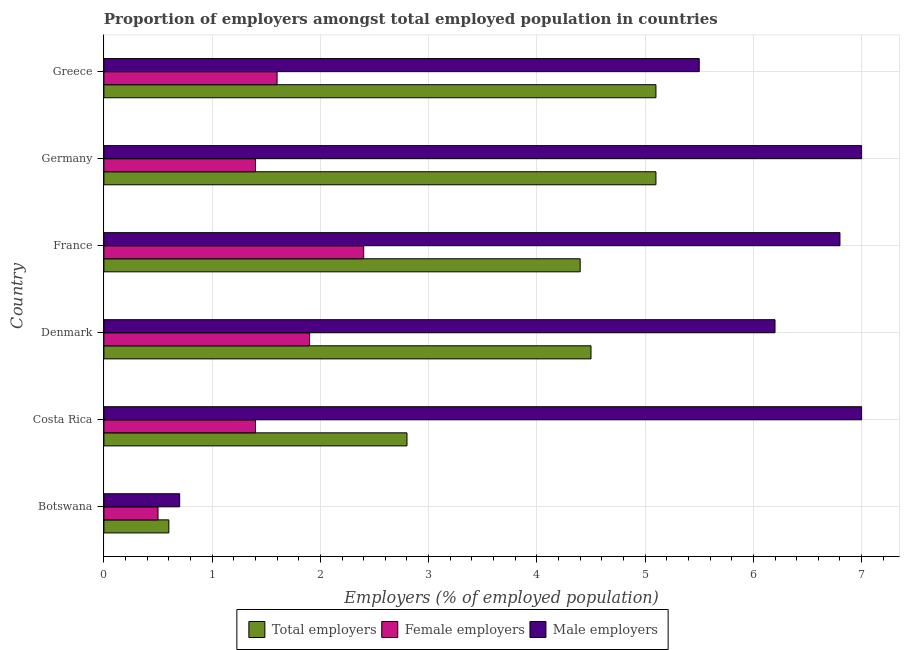How many different coloured bars are there?
Your answer should be very brief. 3. How many groups of bars are there?
Offer a very short reply. 6. Are the number of bars on each tick of the Y-axis equal?
Your response must be concise. Yes. How many bars are there on the 5th tick from the top?
Offer a very short reply. 3. How many bars are there on the 2nd tick from the bottom?
Keep it short and to the point. 3. In how many cases, is the number of bars for a given country not equal to the number of legend labels?
Ensure brevity in your answer.  0. What is the percentage of female employers in France?
Give a very brief answer. 2.4. Across all countries, what is the minimum percentage of female employers?
Provide a short and direct response. 0.5. In which country was the percentage of female employers maximum?
Make the answer very short. France. In which country was the percentage of male employers minimum?
Ensure brevity in your answer.  Botswana. What is the total percentage of male employers in the graph?
Give a very brief answer. 33.2. What is the difference between the percentage of female employers in Botswana and that in Greece?
Your answer should be compact. -1.1. What is the difference between the percentage of total employers in Costa Rica and the percentage of male employers in Denmark?
Your response must be concise. -3.4. What is the average percentage of male employers per country?
Make the answer very short. 5.53. What is the ratio of the percentage of total employers in Costa Rica to that in Germany?
Offer a very short reply. 0.55. Is the percentage of female employers in Costa Rica less than that in Greece?
Provide a short and direct response. Yes. What is the difference between the highest and the second highest percentage of female employers?
Offer a terse response. 0.5. What does the 1st bar from the top in Denmark represents?
Provide a short and direct response. Male employers. What does the 1st bar from the bottom in Botswana represents?
Your answer should be compact. Total employers. How many bars are there?
Give a very brief answer. 18. Are all the bars in the graph horizontal?
Your answer should be compact. Yes. How many countries are there in the graph?
Provide a succinct answer. 6. What is the difference between two consecutive major ticks on the X-axis?
Ensure brevity in your answer.  1. Are the values on the major ticks of X-axis written in scientific E-notation?
Provide a short and direct response. No. Does the graph contain grids?
Make the answer very short. Yes. Where does the legend appear in the graph?
Offer a terse response. Bottom center. What is the title of the graph?
Make the answer very short. Proportion of employers amongst total employed population in countries. Does "Methane" appear as one of the legend labels in the graph?
Make the answer very short. No. What is the label or title of the X-axis?
Your response must be concise. Employers (% of employed population). What is the Employers (% of employed population) in Total employers in Botswana?
Your answer should be compact. 0.6. What is the Employers (% of employed population) of Female employers in Botswana?
Offer a very short reply. 0.5. What is the Employers (% of employed population) in Male employers in Botswana?
Your answer should be compact. 0.7. What is the Employers (% of employed population) of Total employers in Costa Rica?
Give a very brief answer. 2.8. What is the Employers (% of employed population) in Female employers in Costa Rica?
Make the answer very short. 1.4. What is the Employers (% of employed population) in Male employers in Costa Rica?
Provide a succinct answer. 7. What is the Employers (% of employed population) of Total employers in Denmark?
Your answer should be compact. 4.5. What is the Employers (% of employed population) in Female employers in Denmark?
Keep it short and to the point. 1.9. What is the Employers (% of employed population) in Male employers in Denmark?
Your answer should be compact. 6.2. What is the Employers (% of employed population) in Total employers in France?
Give a very brief answer. 4.4. What is the Employers (% of employed population) in Female employers in France?
Your response must be concise. 2.4. What is the Employers (% of employed population) in Male employers in France?
Your answer should be compact. 6.8. What is the Employers (% of employed population) of Total employers in Germany?
Your answer should be very brief. 5.1. What is the Employers (% of employed population) of Female employers in Germany?
Make the answer very short. 1.4. What is the Employers (% of employed population) of Total employers in Greece?
Ensure brevity in your answer.  5.1. What is the Employers (% of employed population) in Female employers in Greece?
Your response must be concise. 1.6. Across all countries, what is the maximum Employers (% of employed population) of Total employers?
Provide a succinct answer. 5.1. Across all countries, what is the maximum Employers (% of employed population) of Female employers?
Your response must be concise. 2.4. Across all countries, what is the minimum Employers (% of employed population) in Total employers?
Your answer should be compact. 0.6. Across all countries, what is the minimum Employers (% of employed population) in Female employers?
Ensure brevity in your answer.  0.5. Across all countries, what is the minimum Employers (% of employed population) in Male employers?
Give a very brief answer. 0.7. What is the total Employers (% of employed population) of Male employers in the graph?
Keep it short and to the point. 33.2. What is the difference between the Employers (% of employed population) in Female employers in Botswana and that in Denmark?
Provide a succinct answer. -1.4. What is the difference between the Employers (% of employed population) in Male employers in Botswana and that in Denmark?
Provide a succinct answer. -5.5. What is the difference between the Employers (% of employed population) of Female employers in Botswana and that in France?
Offer a very short reply. -1.9. What is the difference between the Employers (% of employed population) of Female employers in Botswana and that in Germany?
Offer a very short reply. -0.9. What is the difference between the Employers (% of employed population) of Total employers in Botswana and that in Greece?
Provide a succinct answer. -4.5. What is the difference between the Employers (% of employed population) of Female employers in Botswana and that in Greece?
Offer a terse response. -1.1. What is the difference between the Employers (% of employed population) of Male employers in Botswana and that in Greece?
Offer a very short reply. -4.8. What is the difference between the Employers (% of employed population) in Total employers in Costa Rica and that in Denmark?
Offer a terse response. -1.7. What is the difference between the Employers (% of employed population) in Female employers in Costa Rica and that in Denmark?
Keep it short and to the point. -0.5. What is the difference between the Employers (% of employed population) in Male employers in Costa Rica and that in France?
Your response must be concise. 0.2. What is the difference between the Employers (% of employed population) of Total employers in Costa Rica and that in Germany?
Ensure brevity in your answer.  -2.3. What is the difference between the Employers (% of employed population) in Male employers in Costa Rica and that in Germany?
Offer a very short reply. 0. What is the difference between the Employers (% of employed population) in Female employers in Costa Rica and that in Greece?
Your answer should be compact. -0.2. What is the difference between the Employers (% of employed population) in Male employers in Costa Rica and that in Greece?
Provide a short and direct response. 1.5. What is the difference between the Employers (% of employed population) in Female employers in Denmark and that in France?
Offer a terse response. -0.5. What is the difference between the Employers (% of employed population) of Female employers in Denmark and that in Germany?
Give a very brief answer. 0.5. What is the difference between the Employers (% of employed population) in Total employers in Denmark and that in Greece?
Provide a short and direct response. -0.6. What is the difference between the Employers (% of employed population) in Male employers in Denmark and that in Greece?
Provide a succinct answer. 0.7. What is the difference between the Employers (% of employed population) of Male employers in France and that in Germany?
Offer a terse response. -0.2. What is the difference between the Employers (% of employed population) of Male employers in France and that in Greece?
Offer a terse response. 1.3. What is the difference between the Employers (% of employed population) in Female employers in Germany and that in Greece?
Your answer should be compact. -0.2. What is the difference between the Employers (% of employed population) of Male employers in Germany and that in Greece?
Ensure brevity in your answer.  1.5. What is the difference between the Employers (% of employed population) in Total employers in Botswana and the Employers (% of employed population) in Male employers in Costa Rica?
Your response must be concise. -6.4. What is the difference between the Employers (% of employed population) of Female employers in Botswana and the Employers (% of employed population) of Male employers in Costa Rica?
Provide a short and direct response. -6.5. What is the difference between the Employers (% of employed population) of Total employers in Botswana and the Employers (% of employed population) of Female employers in France?
Provide a succinct answer. -1.8. What is the difference between the Employers (% of employed population) of Total employers in Botswana and the Employers (% of employed population) of Male employers in France?
Offer a terse response. -6.2. What is the difference between the Employers (% of employed population) in Female employers in Botswana and the Employers (% of employed population) in Male employers in France?
Offer a very short reply. -6.3. What is the difference between the Employers (% of employed population) of Total employers in Botswana and the Employers (% of employed population) of Female employers in Germany?
Offer a very short reply. -0.8. What is the difference between the Employers (% of employed population) of Total employers in Botswana and the Employers (% of employed population) of Male employers in Germany?
Your answer should be very brief. -6.4. What is the difference between the Employers (% of employed population) in Female employers in Botswana and the Employers (% of employed population) in Male employers in Germany?
Keep it short and to the point. -6.5. What is the difference between the Employers (% of employed population) of Total employers in Botswana and the Employers (% of employed population) of Male employers in Greece?
Provide a succinct answer. -4.9. What is the difference between the Employers (% of employed population) of Female employers in Botswana and the Employers (% of employed population) of Male employers in Greece?
Ensure brevity in your answer.  -5. What is the difference between the Employers (% of employed population) in Total employers in Costa Rica and the Employers (% of employed population) in Male employers in Denmark?
Keep it short and to the point. -3.4. What is the difference between the Employers (% of employed population) in Female employers in Costa Rica and the Employers (% of employed population) in Male employers in France?
Offer a terse response. -5.4. What is the difference between the Employers (% of employed population) in Total employers in Costa Rica and the Employers (% of employed population) in Male employers in Germany?
Your answer should be compact. -4.2. What is the difference between the Employers (% of employed population) in Female employers in Costa Rica and the Employers (% of employed population) in Male employers in Germany?
Keep it short and to the point. -5.6. What is the difference between the Employers (% of employed population) of Female employers in Costa Rica and the Employers (% of employed population) of Male employers in Greece?
Offer a terse response. -4.1. What is the difference between the Employers (% of employed population) of Total employers in Denmark and the Employers (% of employed population) of Female employers in France?
Make the answer very short. 2.1. What is the difference between the Employers (% of employed population) in Total employers in Denmark and the Employers (% of employed population) in Male employers in France?
Your response must be concise. -2.3. What is the difference between the Employers (% of employed population) in Female employers in Denmark and the Employers (% of employed population) in Male employers in Germany?
Offer a very short reply. -5.1. What is the difference between the Employers (% of employed population) in Total employers in Denmark and the Employers (% of employed population) in Male employers in Greece?
Offer a terse response. -1. What is the difference between the Employers (% of employed population) of Total employers in France and the Employers (% of employed population) of Female employers in Germany?
Provide a succinct answer. 3. What is the difference between the Employers (% of employed population) in Total employers in France and the Employers (% of employed population) in Male employers in Germany?
Offer a very short reply. -2.6. What is the difference between the Employers (% of employed population) in Total employers in France and the Employers (% of employed population) in Female employers in Greece?
Give a very brief answer. 2.8. What is the difference between the Employers (% of employed population) of Female employers in France and the Employers (% of employed population) of Male employers in Greece?
Give a very brief answer. -3.1. What is the average Employers (% of employed population) of Total employers per country?
Your answer should be compact. 3.75. What is the average Employers (% of employed population) in Female employers per country?
Offer a terse response. 1.53. What is the average Employers (% of employed population) of Male employers per country?
Make the answer very short. 5.53. What is the difference between the Employers (% of employed population) in Total employers and Employers (% of employed population) in Female employers in Botswana?
Give a very brief answer. 0.1. What is the difference between the Employers (% of employed population) of Female employers and Employers (% of employed population) of Male employers in Costa Rica?
Make the answer very short. -5.6. What is the difference between the Employers (% of employed population) in Total employers and Employers (% of employed population) in Female employers in Denmark?
Provide a succinct answer. 2.6. What is the difference between the Employers (% of employed population) in Total employers and Employers (% of employed population) in Male employers in Denmark?
Your answer should be very brief. -1.7. What is the difference between the Employers (% of employed population) in Total employers and Employers (% of employed population) in Male employers in France?
Ensure brevity in your answer.  -2.4. What is the difference between the Employers (% of employed population) in Female employers and Employers (% of employed population) in Male employers in Germany?
Provide a succinct answer. -5.6. What is the difference between the Employers (% of employed population) in Total employers and Employers (% of employed population) in Female employers in Greece?
Your response must be concise. 3.5. What is the difference between the Employers (% of employed population) of Female employers and Employers (% of employed population) of Male employers in Greece?
Offer a very short reply. -3.9. What is the ratio of the Employers (% of employed population) in Total employers in Botswana to that in Costa Rica?
Your answer should be compact. 0.21. What is the ratio of the Employers (% of employed population) in Female employers in Botswana to that in Costa Rica?
Your answer should be very brief. 0.36. What is the ratio of the Employers (% of employed population) in Male employers in Botswana to that in Costa Rica?
Your answer should be compact. 0.1. What is the ratio of the Employers (% of employed population) in Total employers in Botswana to that in Denmark?
Ensure brevity in your answer.  0.13. What is the ratio of the Employers (% of employed population) of Female employers in Botswana to that in Denmark?
Your response must be concise. 0.26. What is the ratio of the Employers (% of employed population) in Male employers in Botswana to that in Denmark?
Your response must be concise. 0.11. What is the ratio of the Employers (% of employed population) of Total employers in Botswana to that in France?
Make the answer very short. 0.14. What is the ratio of the Employers (% of employed population) in Female employers in Botswana to that in France?
Keep it short and to the point. 0.21. What is the ratio of the Employers (% of employed population) of Male employers in Botswana to that in France?
Ensure brevity in your answer.  0.1. What is the ratio of the Employers (% of employed population) of Total employers in Botswana to that in Germany?
Give a very brief answer. 0.12. What is the ratio of the Employers (% of employed population) in Female employers in Botswana to that in Germany?
Make the answer very short. 0.36. What is the ratio of the Employers (% of employed population) in Total employers in Botswana to that in Greece?
Keep it short and to the point. 0.12. What is the ratio of the Employers (% of employed population) in Female employers in Botswana to that in Greece?
Your answer should be compact. 0.31. What is the ratio of the Employers (% of employed population) of Male employers in Botswana to that in Greece?
Make the answer very short. 0.13. What is the ratio of the Employers (% of employed population) in Total employers in Costa Rica to that in Denmark?
Provide a short and direct response. 0.62. What is the ratio of the Employers (% of employed population) of Female employers in Costa Rica to that in Denmark?
Ensure brevity in your answer.  0.74. What is the ratio of the Employers (% of employed population) in Male employers in Costa Rica to that in Denmark?
Your response must be concise. 1.13. What is the ratio of the Employers (% of employed population) in Total employers in Costa Rica to that in France?
Make the answer very short. 0.64. What is the ratio of the Employers (% of employed population) of Female employers in Costa Rica to that in France?
Offer a terse response. 0.58. What is the ratio of the Employers (% of employed population) in Male employers in Costa Rica to that in France?
Give a very brief answer. 1.03. What is the ratio of the Employers (% of employed population) of Total employers in Costa Rica to that in Germany?
Provide a short and direct response. 0.55. What is the ratio of the Employers (% of employed population) in Female employers in Costa Rica to that in Germany?
Your answer should be compact. 1. What is the ratio of the Employers (% of employed population) in Male employers in Costa Rica to that in Germany?
Give a very brief answer. 1. What is the ratio of the Employers (% of employed population) of Total employers in Costa Rica to that in Greece?
Offer a very short reply. 0.55. What is the ratio of the Employers (% of employed population) of Male employers in Costa Rica to that in Greece?
Ensure brevity in your answer.  1.27. What is the ratio of the Employers (% of employed population) of Total employers in Denmark to that in France?
Ensure brevity in your answer.  1.02. What is the ratio of the Employers (% of employed population) of Female employers in Denmark to that in France?
Your answer should be very brief. 0.79. What is the ratio of the Employers (% of employed population) of Male employers in Denmark to that in France?
Provide a succinct answer. 0.91. What is the ratio of the Employers (% of employed population) in Total employers in Denmark to that in Germany?
Ensure brevity in your answer.  0.88. What is the ratio of the Employers (% of employed population) in Female employers in Denmark to that in Germany?
Offer a terse response. 1.36. What is the ratio of the Employers (% of employed population) of Male employers in Denmark to that in Germany?
Provide a short and direct response. 0.89. What is the ratio of the Employers (% of employed population) of Total employers in Denmark to that in Greece?
Keep it short and to the point. 0.88. What is the ratio of the Employers (% of employed population) of Female employers in Denmark to that in Greece?
Offer a very short reply. 1.19. What is the ratio of the Employers (% of employed population) in Male employers in Denmark to that in Greece?
Provide a short and direct response. 1.13. What is the ratio of the Employers (% of employed population) of Total employers in France to that in Germany?
Ensure brevity in your answer.  0.86. What is the ratio of the Employers (% of employed population) of Female employers in France to that in Germany?
Provide a short and direct response. 1.71. What is the ratio of the Employers (% of employed population) in Male employers in France to that in Germany?
Provide a succinct answer. 0.97. What is the ratio of the Employers (% of employed population) of Total employers in France to that in Greece?
Offer a very short reply. 0.86. What is the ratio of the Employers (% of employed population) in Female employers in France to that in Greece?
Provide a short and direct response. 1.5. What is the ratio of the Employers (% of employed population) of Male employers in France to that in Greece?
Your response must be concise. 1.24. What is the ratio of the Employers (% of employed population) in Total employers in Germany to that in Greece?
Your answer should be compact. 1. What is the ratio of the Employers (% of employed population) in Female employers in Germany to that in Greece?
Provide a short and direct response. 0.88. What is the ratio of the Employers (% of employed population) in Male employers in Germany to that in Greece?
Make the answer very short. 1.27. What is the difference between the highest and the second highest Employers (% of employed population) in Total employers?
Your answer should be very brief. 0. What is the difference between the highest and the lowest Employers (% of employed population) of Male employers?
Provide a succinct answer. 6.3. 